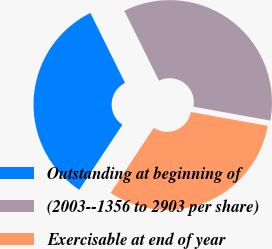Convert chart. <chart><loc_0><loc_0><loc_500><loc_500><pie_chart><fcel>Outstanding at beginning of<fcel>(2003--1356 to 2903 per share)<fcel>Exercisable at end of year<nl><fcel>33.36%<fcel>35.17%<fcel>31.47%<nl></chart> 